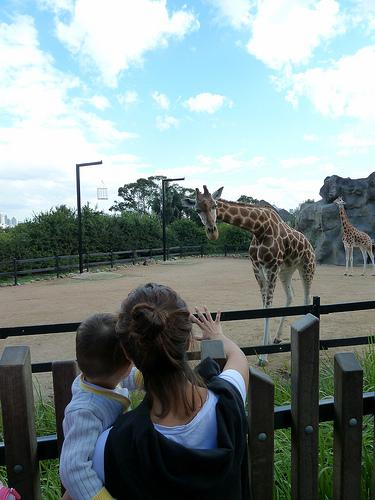Question: how many giraffes are in the picture?
Choices:
A. Three.
B. Four.
C. Two.
D. Five.
Answer with the letter. Answer: C Question: how many lamp posts are there?
Choices:
A. Four.
B. Six.
C. Eight.
D. Two.
Answer with the letter. Answer: D Question: what are the people looking at?
Choices:
A. Parachuting people.
B. Giraffes.
C. Car crash.
D. Football game.
Answer with the letter. Answer: B 